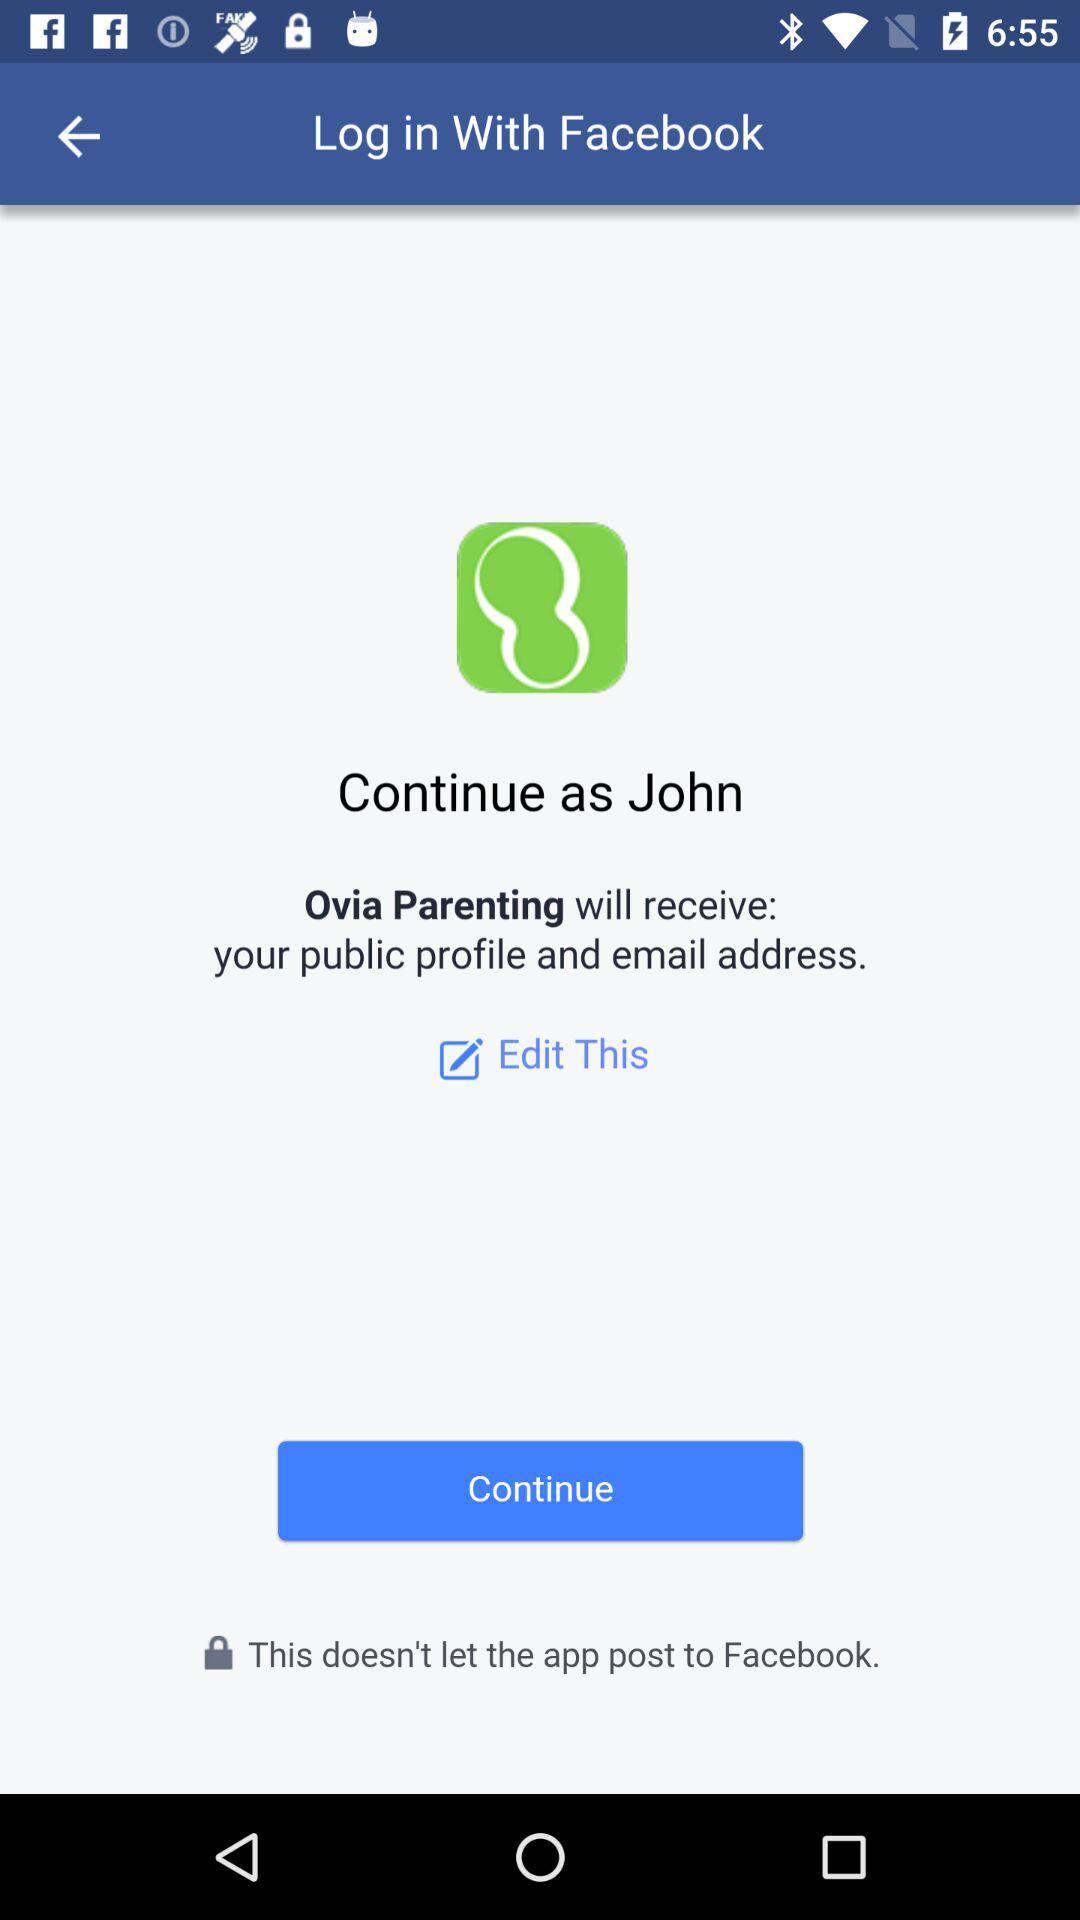What is the name of the user? The name of the user is John. 